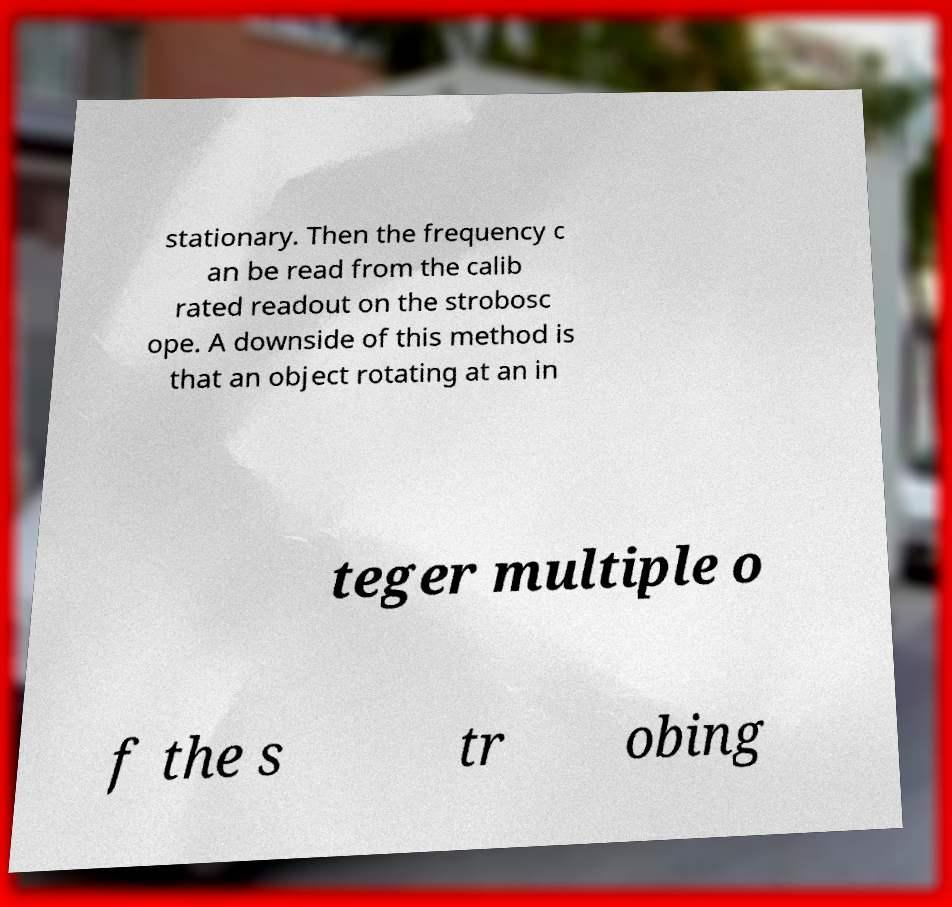Can you read and provide the text displayed in the image?This photo seems to have some interesting text. Can you extract and type it out for me? stationary. Then the frequency c an be read from the calib rated readout on the strobosc ope. A downside of this method is that an object rotating at an in teger multiple o f the s tr obing 